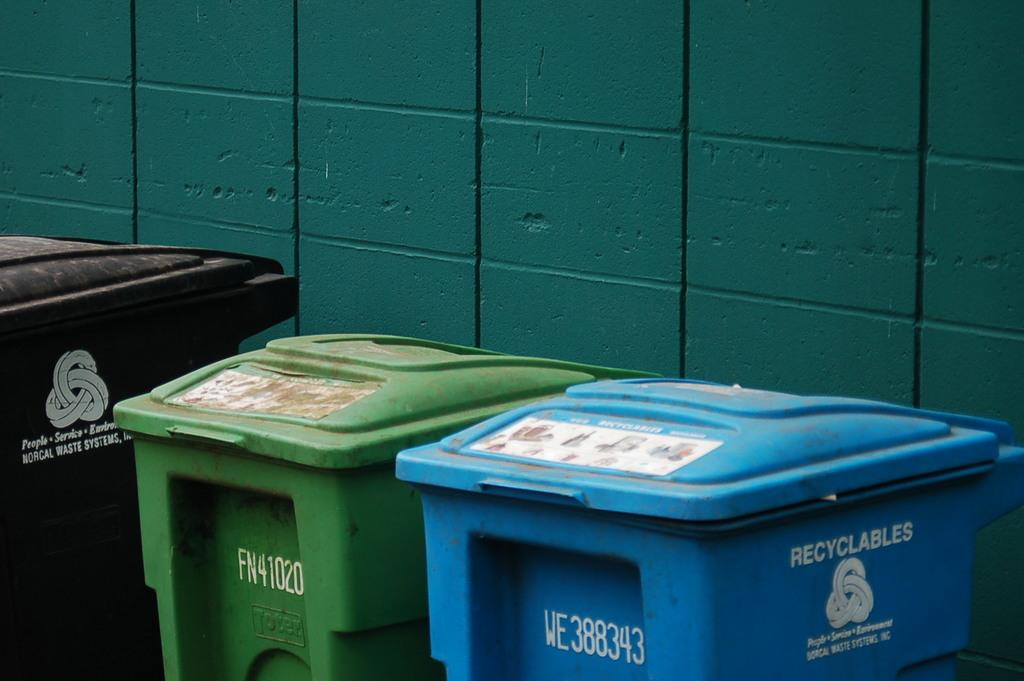How many bins are visible in the image? There are three bins in the image. What can be found on the bins? There is writing on the bins. What color is the wall in the background of the image? The wall in the background of the image is green. How long does it take for the bins to smash in the image? There is no indication in the image that the bins are smashing or will smash, so it cannot be determined from the image. 